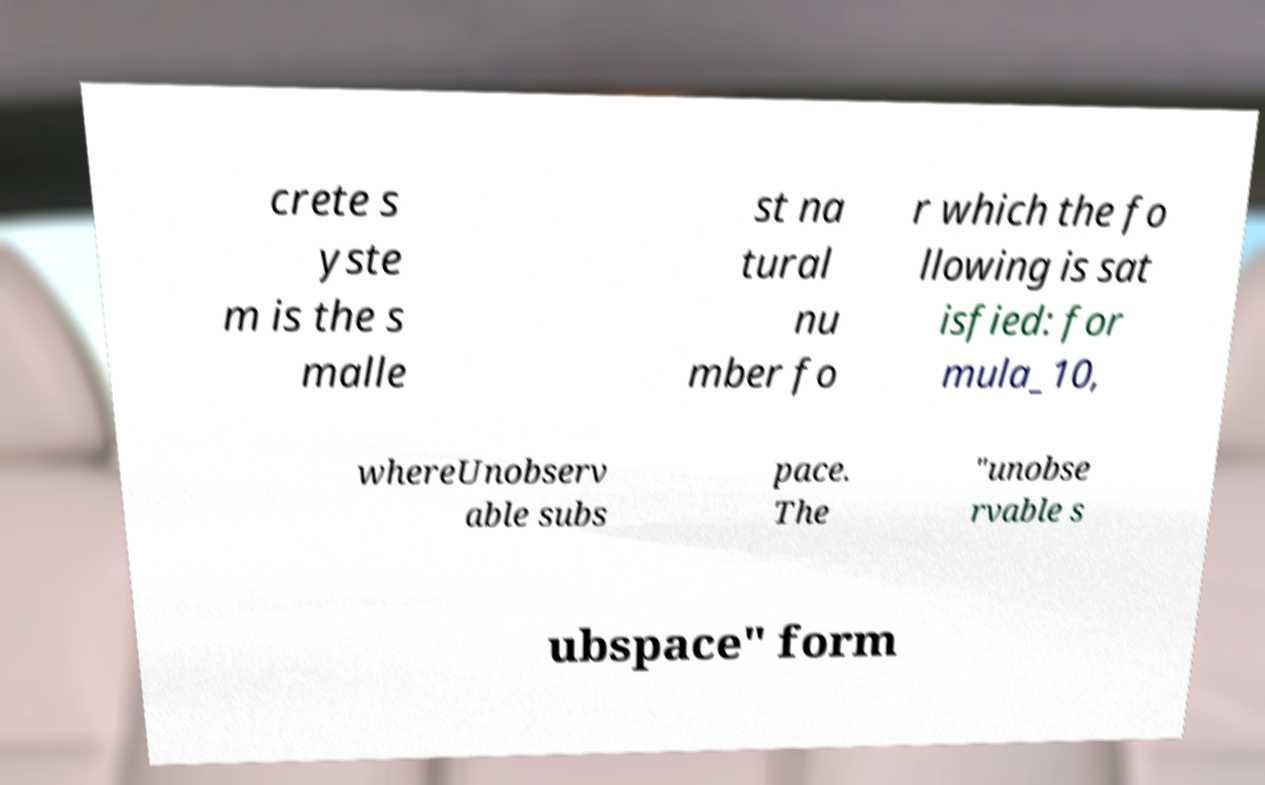For documentation purposes, I need the text within this image transcribed. Could you provide that? crete s yste m is the s malle st na tural nu mber fo r which the fo llowing is sat isfied: for mula_10, whereUnobserv able subs pace. The "unobse rvable s ubspace" form 